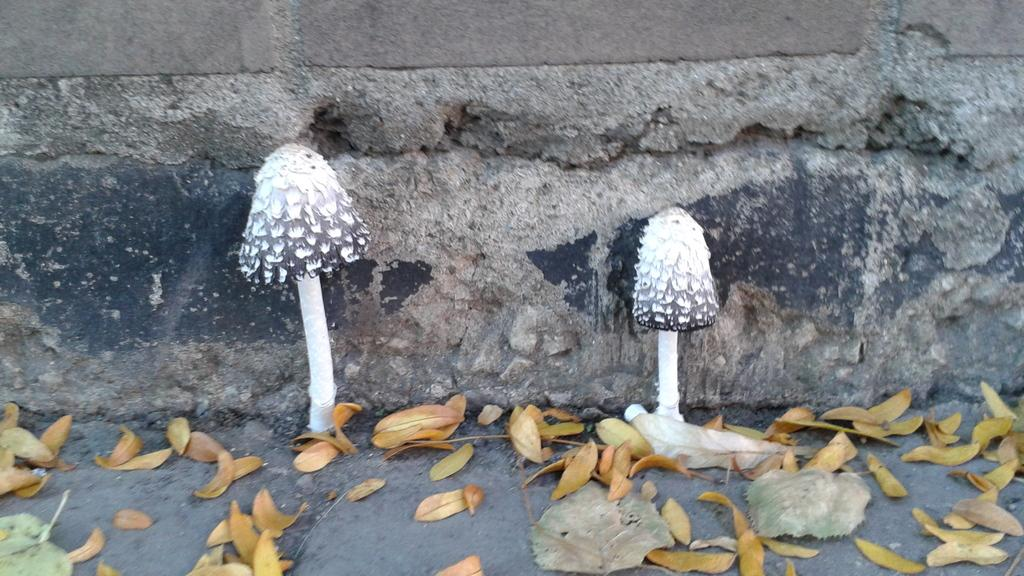What type of fungi can be seen in the front of the image? There are two mushrooms in the front of the image. What type of vegetation is present at the bottom of the image? There are leaves at the bottom of the image. What type of structure can be seen in the background of the image? There is a wall visible in the background of the image. What type of knowledge can be gained from the mushrooms in the image? There is no knowledge to be gained from the mushrooms in the image; they are simply fungi. 